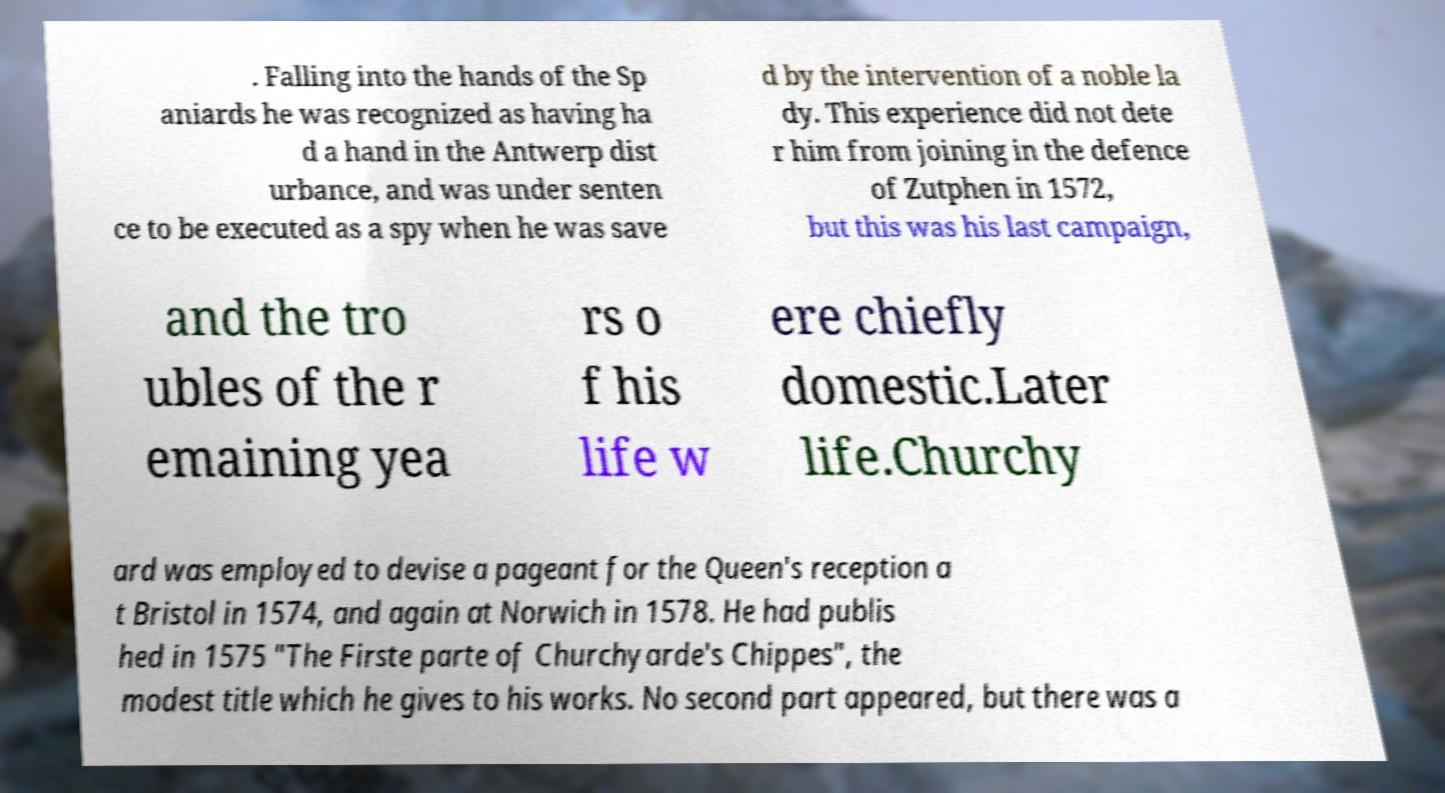There's text embedded in this image that I need extracted. Can you transcribe it verbatim? . Falling into the hands of the Sp aniards he was recognized as having ha d a hand in the Antwerp dist urbance, and was under senten ce to be executed as a spy when he was save d by the intervention of a noble la dy. This experience did not dete r him from joining in the defence of Zutphen in 1572, but this was his last campaign, and the tro ubles of the r emaining yea rs o f his life w ere chiefly domestic.Later life.Churchy ard was employed to devise a pageant for the Queen's reception a t Bristol in 1574, and again at Norwich in 1578. He had publis hed in 1575 "The Firste parte of Churchyarde's Chippes", the modest title which he gives to his works. No second part appeared, but there was a 